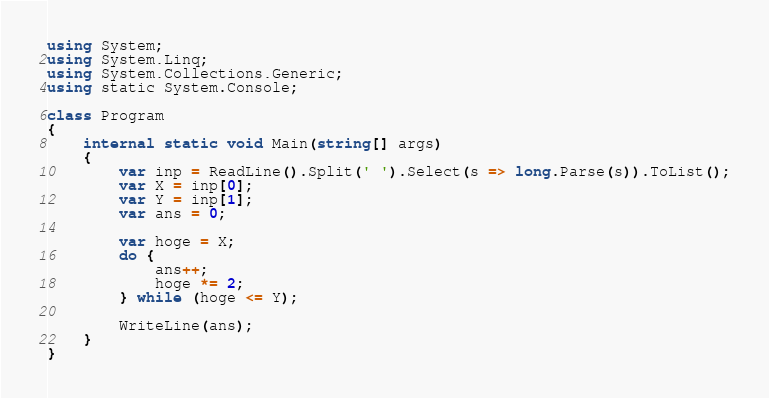<code> <loc_0><loc_0><loc_500><loc_500><_C#_>using System;
using System.Linq;
using System.Collections.Generic;
using static System.Console;

class Program
{
    internal static void Main(string[] args)
    {
        var inp = ReadLine().Split(' ').Select(s => long.Parse(s)).ToList();
        var X = inp[0];
        var Y = inp[1];
        var ans = 0;

        var hoge = X;
        do {
            ans++;
            hoge *= 2;
        } while (hoge <= Y);

        WriteLine(ans);
    }
}
</code> 